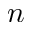Convert formula to latex. <formula><loc_0><loc_0><loc_500><loc_500>n</formula> 